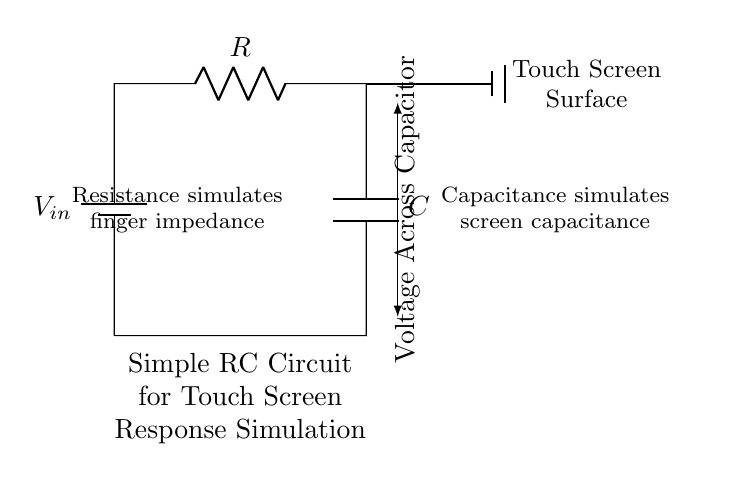What is the type of circuit represented? The circuit is an RC circuit, which consists of a resistor and a capacitor in series. RC circuits are commonly used in timing applications and can simulate response characteristics such as touchscreen latency.
Answer: RC circuit What is the role of the resistor in this circuit? The resistor simulates finger impedance by limiting the current flow in the circuit, which affects how quickly the capacitor charges or discharges. This behavior models the response time of the touchscreen to a finger touch.
Answer: Finger impedance What does the capacitor represent in this circuit? The capacitor represents the capacitance of the touchscreen surface, which stores electric charge and impacts the response time when a finger makes contact. The charging time of the capacitor will influence how quickly the touchscreen can detect a touch.
Answer: Screen capacitance What is the relationship between voltage and the capacitor in this circuit? The voltage across the capacitor indicates how much charge it has stored, correlating with the time it takes to respond when a touch is detected. The voltage increases as the capacitor charges and decreases as it discharges.
Answer: Charge stored How does increasing the resistance affect the response time? Increasing the resistance will slow down the charging and discharging of the capacitor, resulting in a longer response time for the touchscreen. This is due to the formula for time constant, which is the product of resistance and capacitance, influencing the speed of voltage changes across the capacitor.
Answer: Slower response time What component simulates the touch screen’s interaction with a finger? The resistor simulates the interaction by representing the impedance of a finger. The resistance value is critical because it dictates how the circuit reacts to an applied touch, affecting the timing for how the information is relayed.
Answer: Resistor What is indicated by the vertical arrow showing voltage across the capacitor? The arrow indicates the measurement of voltage across the capacitor, which is critical for understanding how much charge it has at any given time. This measurement helps in simulating the time response characteristic of a touchscreen.
Answer: Voltage measurement 